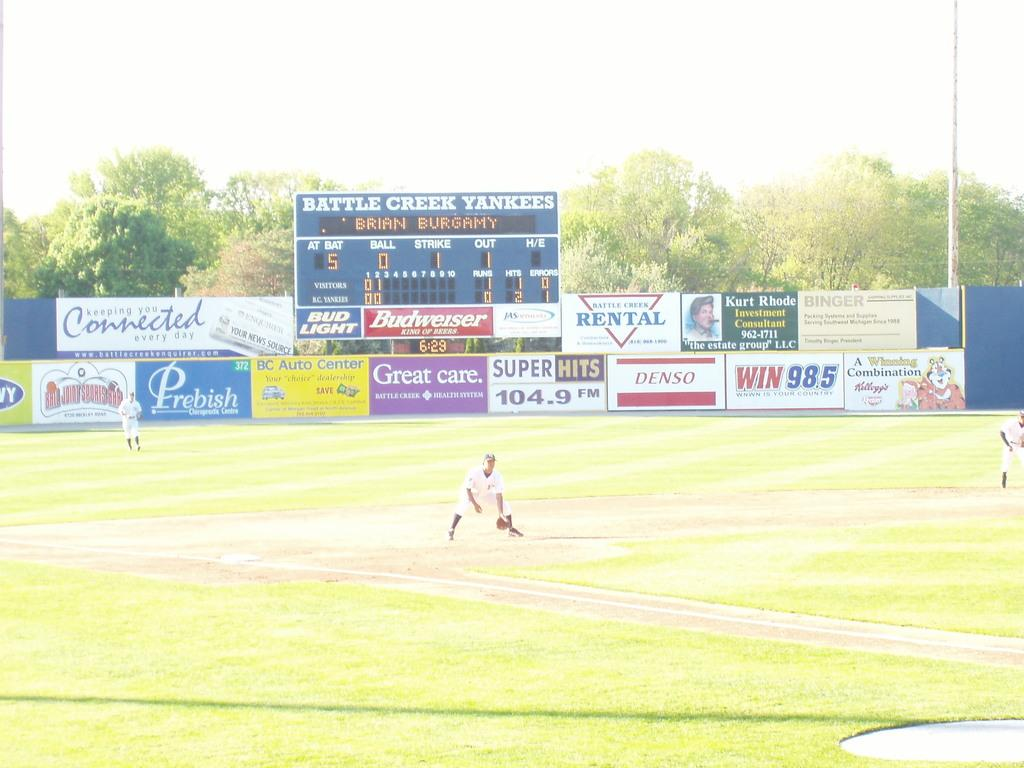How many people are in the image? There are three people in the image. What can be seen in the background of the image? Hoardings, a digital scoreboard, a pole, trees, and the sky are visible in the background of the image. Can you describe the pole in the background? The pole is a vertical structure that can be seen in the background of the image. What type of sofa is visible in the image? There is no sofa present in the image. What game is being played on the digital scoreboard in the image? The image does not show any game being played on the digital scoreboard; it only shows the scoreboard itself. 